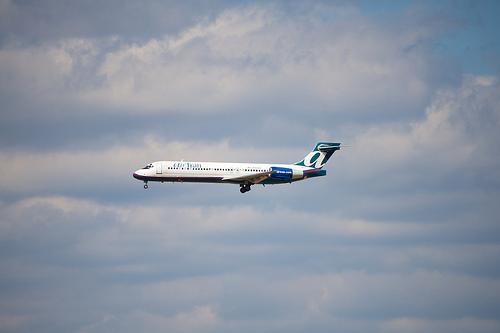How many planes are there?
Give a very brief answer. 1. 